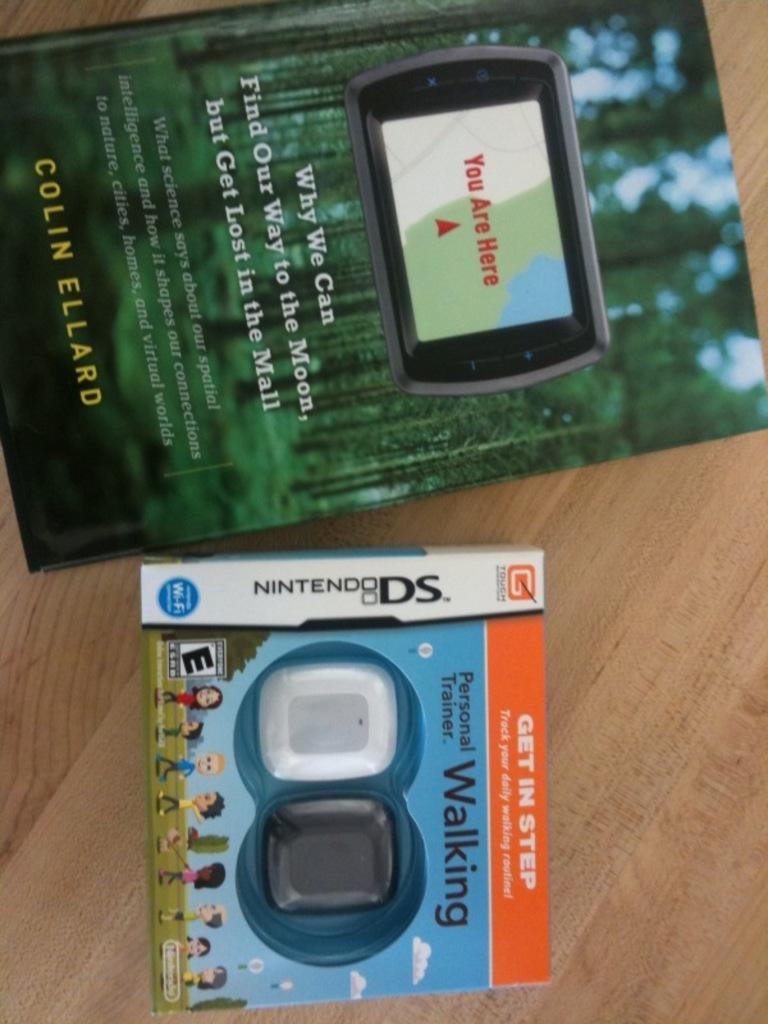<image>
Offer a succinct explanation of the picture presented. A Nintendo DS game has the word walking on it. 